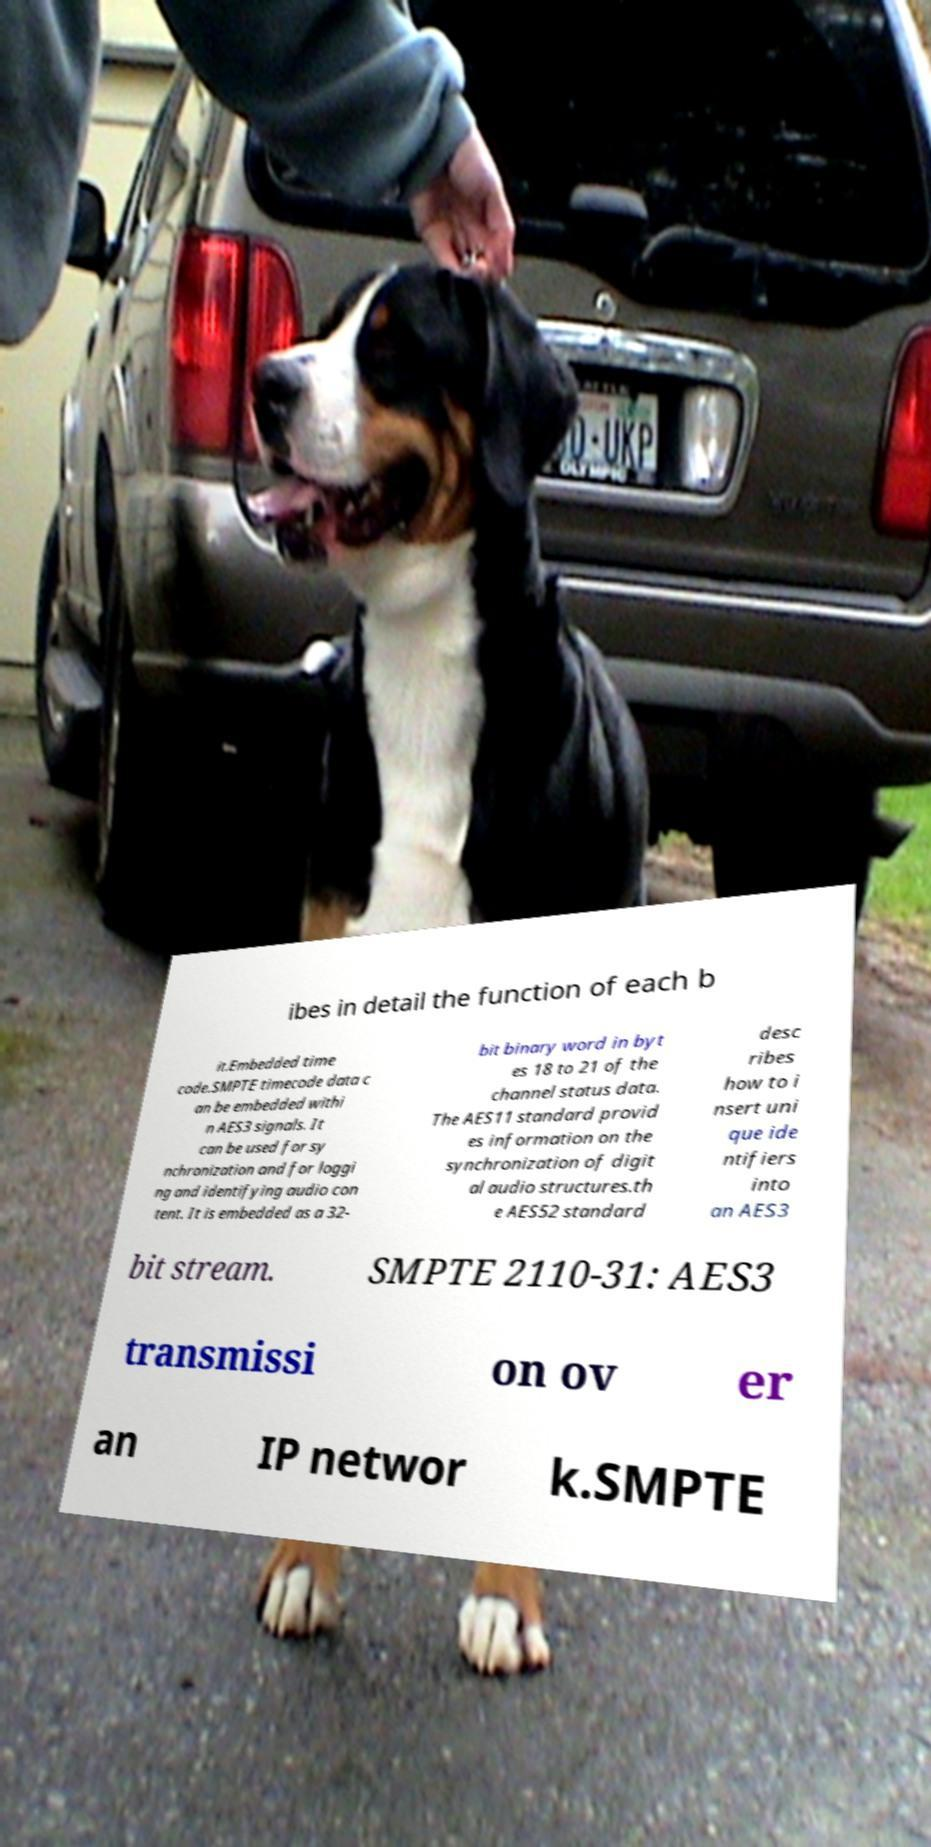Can you read and provide the text displayed in the image?This photo seems to have some interesting text. Can you extract and type it out for me? ibes in detail the function of each b it.Embedded time code.SMPTE timecode data c an be embedded withi n AES3 signals. It can be used for sy nchronization and for loggi ng and identifying audio con tent. It is embedded as a 32- bit binary word in byt es 18 to 21 of the channel status data. The AES11 standard provid es information on the synchronization of digit al audio structures.th e AES52 standard desc ribes how to i nsert uni que ide ntifiers into an AES3 bit stream. SMPTE 2110-31: AES3 transmissi on ov er an IP networ k.SMPTE 